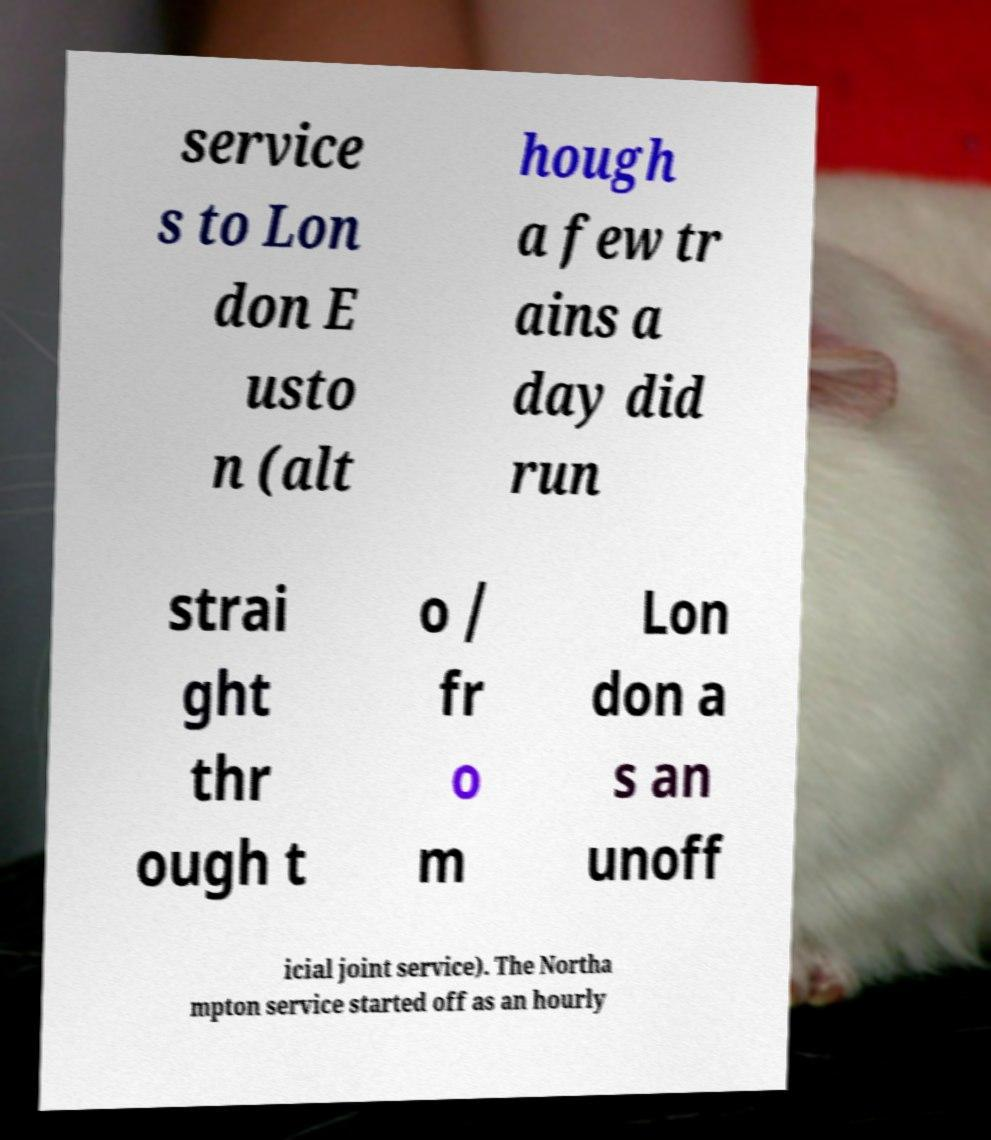Please read and relay the text visible in this image. What does it say? service s to Lon don E usto n (alt hough a few tr ains a day did run strai ght thr ough t o / fr o m Lon don a s an unoff icial joint service). The Northa mpton service started off as an hourly 